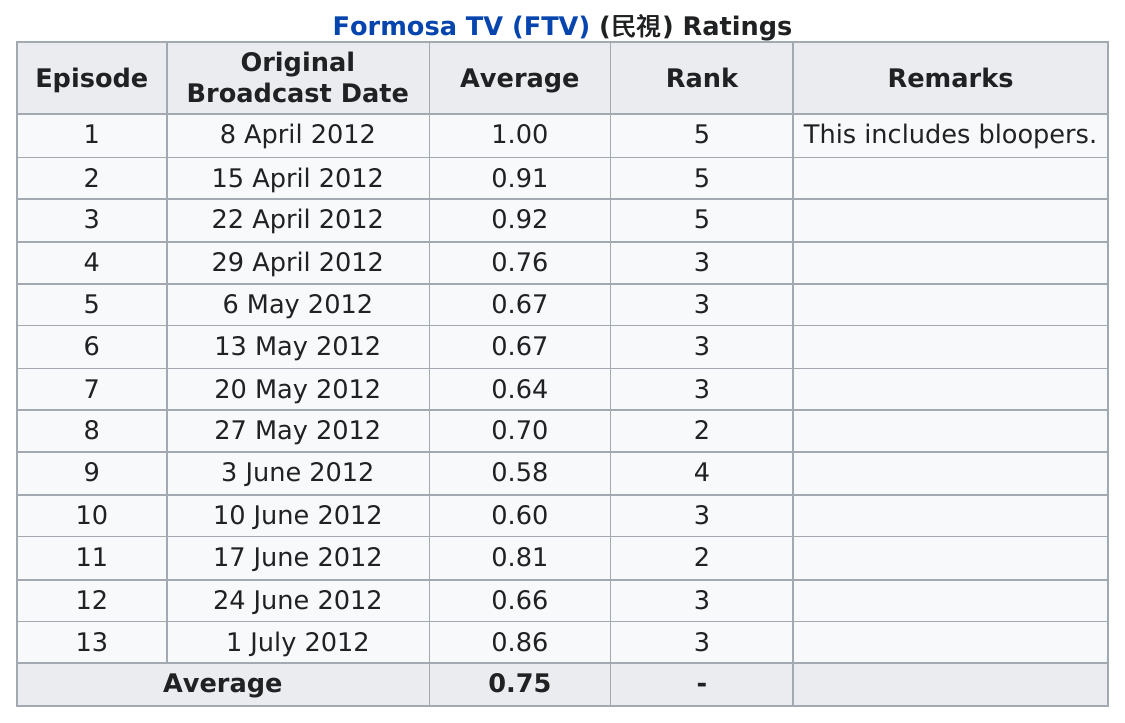Indicate a few pertinent items in this graphic. The next episode was broadcast on June 3rd, 2012. Four aired in May. Out of the total number of episodes that had at least an average of 0.70, there were 7 of them. Out of the total number of episodes, how many had a rank higher than 3? Out of the total number of episodes, how many had an average rating of over 0.75? The answer is six episodes. 